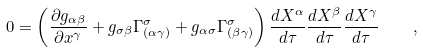<formula> <loc_0><loc_0><loc_500><loc_500>0 = \left ( \frac { \partial { g _ { \alpha \beta } } } { \partial { x ^ { \gamma } } } + g _ { \sigma \beta } \Gamma ^ { \sigma } _ { ( \alpha \gamma ) } + g _ { \alpha \sigma } \Gamma ^ { \sigma } _ { ( \beta \gamma ) } \right ) \frac { d X ^ { \alpha } } { d \tau } \frac { d X ^ { \beta } } { d \tau } \frac { d X ^ { \gamma } } { d \tau } \quad ,</formula> 